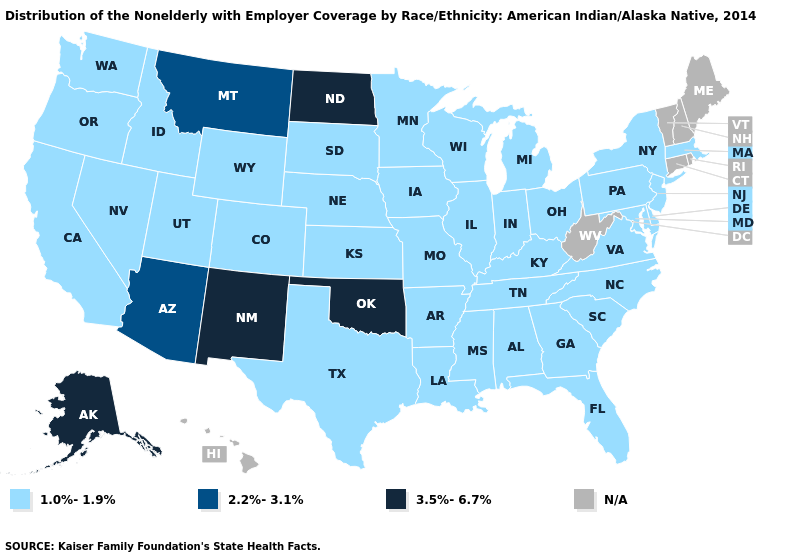How many symbols are there in the legend?
Keep it brief. 4. Which states have the lowest value in the USA?
Give a very brief answer. Alabama, Arkansas, California, Colorado, Delaware, Florida, Georgia, Idaho, Illinois, Indiana, Iowa, Kansas, Kentucky, Louisiana, Maryland, Massachusetts, Michigan, Minnesota, Mississippi, Missouri, Nebraska, Nevada, New Jersey, New York, North Carolina, Ohio, Oregon, Pennsylvania, South Carolina, South Dakota, Tennessee, Texas, Utah, Virginia, Washington, Wisconsin, Wyoming. Name the states that have a value in the range 3.5%-6.7%?
Keep it brief. Alaska, New Mexico, North Dakota, Oklahoma. Among the states that border Oklahoma , does Missouri have the lowest value?
Answer briefly. Yes. Does Oklahoma have the lowest value in the USA?
Give a very brief answer. No. Which states have the highest value in the USA?
Keep it brief. Alaska, New Mexico, North Dakota, Oklahoma. What is the value of New Hampshire?
Concise answer only. N/A. Name the states that have a value in the range 1.0%-1.9%?
Keep it brief. Alabama, Arkansas, California, Colorado, Delaware, Florida, Georgia, Idaho, Illinois, Indiana, Iowa, Kansas, Kentucky, Louisiana, Maryland, Massachusetts, Michigan, Minnesota, Mississippi, Missouri, Nebraska, Nevada, New Jersey, New York, North Carolina, Ohio, Oregon, Pennsylvania, South Carolina, South Dakota, Tennessee, Texas, Utah, Virginia, Washington, Wisconsin, Wyoming. Name the states that have a value in the range 1.0%-1.9%?
Write a very short answer. Alabama, Arkansas, California, Colorado, Delaware, Florida, Georgia, Idaho, Illinois, Indiana, Iowa, Kansas, Kentucky, Louisiana, Maryland, Massachusetts, Michigan, Minnesota, Mississippi, Missouri, Nebraska, Nevada, New Jersey, New York, North Carolina, Ohio, Oregon, Pennsylvania, South Carolina, South Dakota, Tennessee, Texas, Utah, Virginia, Washington, Wisconsin, Wyoming. Name the states that have a value in the range 1.0%-1.9%?
Answer briefly. Alabama, Arkansas, California, Colorado, Delaware, Florida, Georgia, Idaho, Illinois, Indiana, Iowa, Kansas, Kentucky, Louisiana, Maryland, Massachusetts, Michigan, Minnesota, Mississippi, Missouri, Nebraska, Nevada, New Jersey, New York, North Carolina, Ohio, Oregon, Pennsylvania, South Carolina, South Dakota, Tennessee, Texas, Utah, Virginia, Washington, Wisconsin, Wyoming. What is the value of New York?
Quick response, please. 1.0%-1.9%. What is the lowest value in the USA?
Write a very short answer. 1.0%-1.9%. Name the states that have a value in the range 1.0%-1.9%?
Give a very brief answer. Alabama, Arkansas, California, Colorado, Delaware, Florida, Georgia, Idaho, Illinois, Indiana, Iowa, Kansas, Kentucky, Louisiana, Maryland, Massachusetts, Michigan, Minnesota, Mississippi, Missouri, Nebraska, Nevada, New Jersey, New York, North Carolina, Ohio, Oregon, Pennsylvania, South Carolina, South Dakota, Tennessee, Texas, Utah, Virginia, Washington, Wisconsin, Wyoming. What is the highest value in the South ?
Write a very short answer. 3.5%-6.7%. What is the value of New York?
Be succinct. 1.0%-1.9%. 